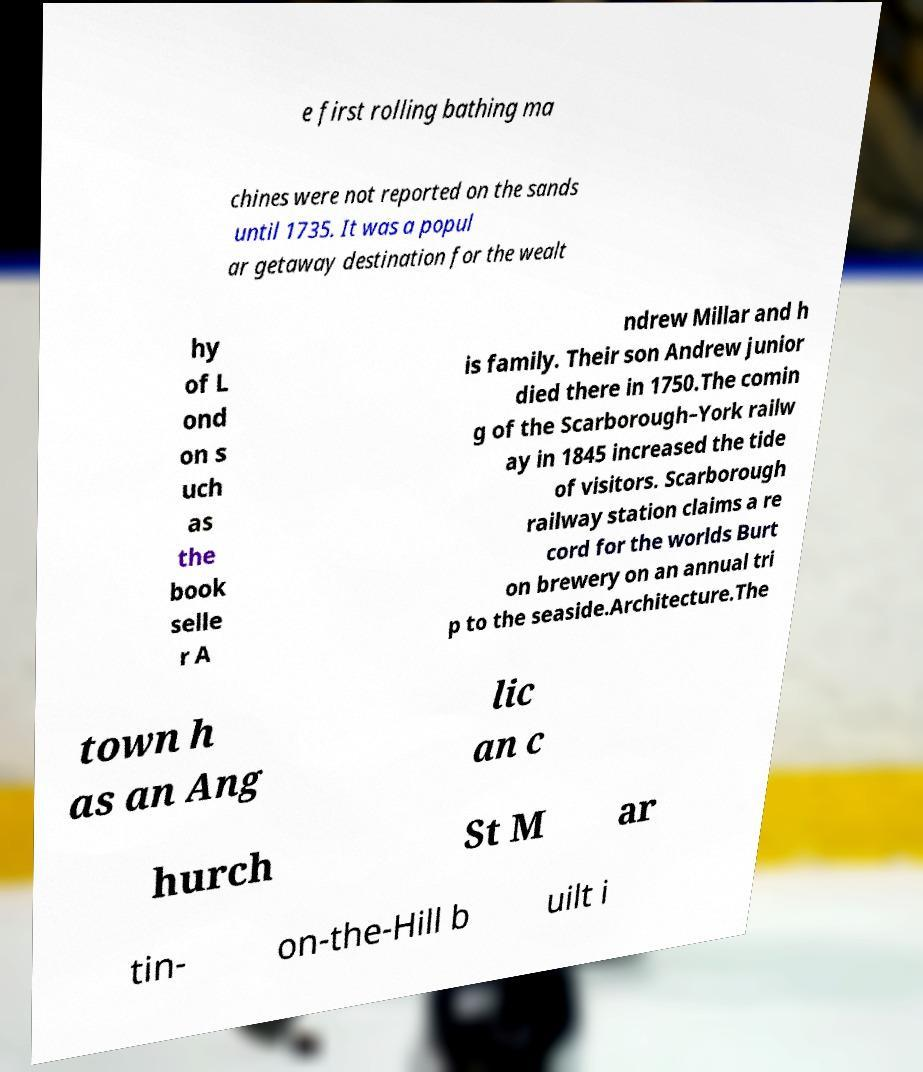Could you extract and type out the text from this image? e first rolling bathing ma chines were not reported on the sands until 1735. It was a popul ar getaway destination for the wealt hy of L ond on s uch as the book selle r A ndrew Millar and h is family. Their son Andrew junior died there in 1750.The comin g of the Scarborough–York railw ay in 1845 increased the tide of visitors. Scarborough railway station claims a re cord for the worlds Burt on brewery on an annual tri p to the seaside.Architecture.The town h as an Ang lic an c hurch St M ar tin- on-the-Hill b uilt i 